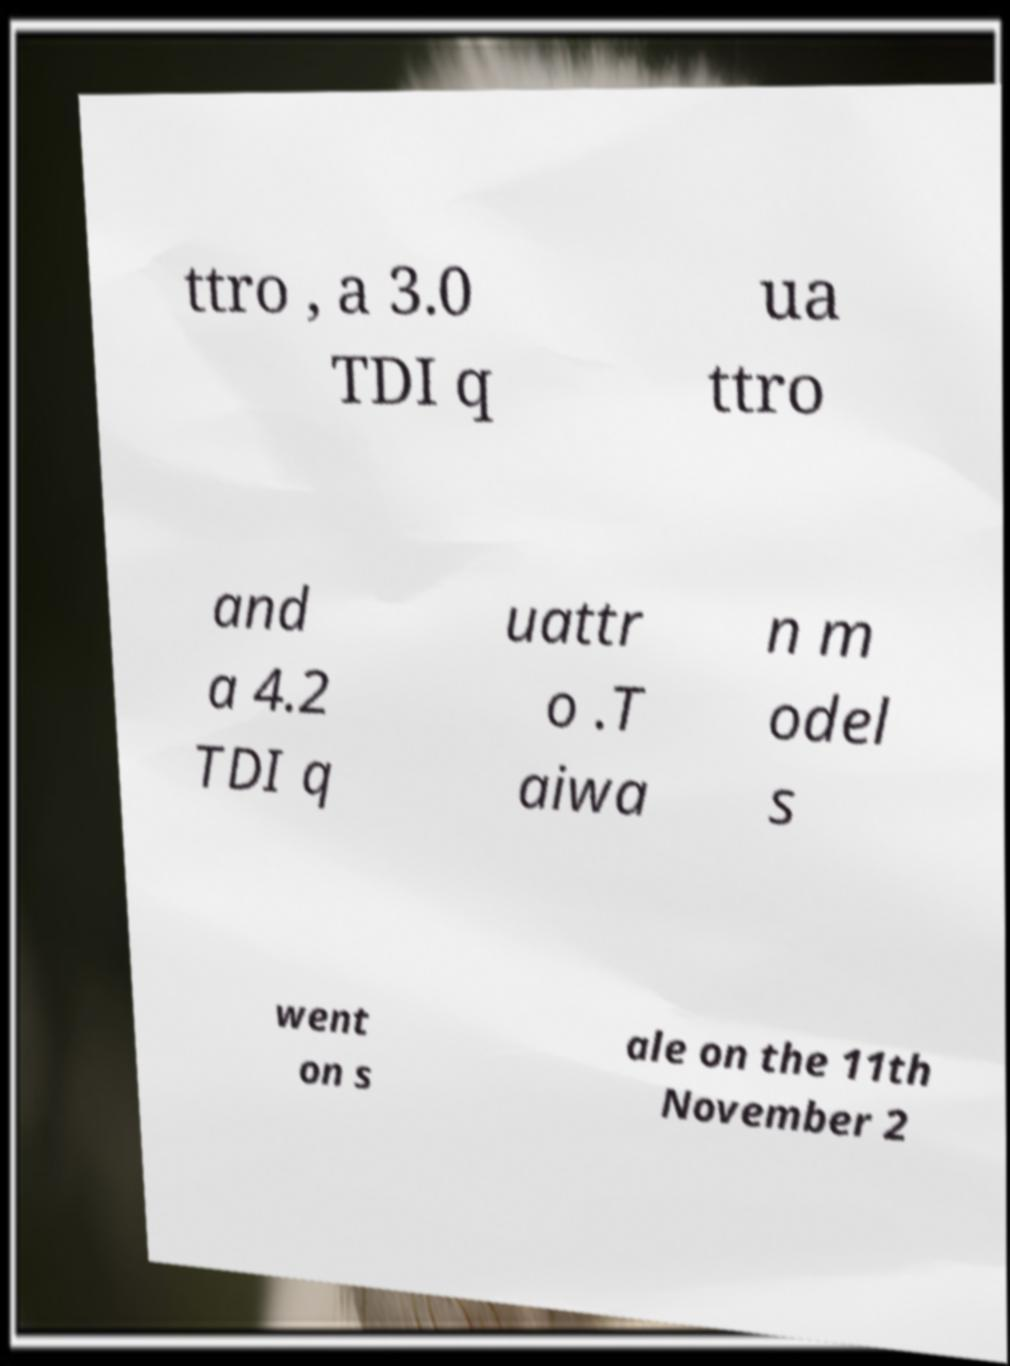Can you accurately transcribe the text from the provided image for me? ttro , a 3.0 TDI q ua ttro and a 4.2 TDI q uattr o .T aiwa n m odel s went on s ale on the 11th November 2 